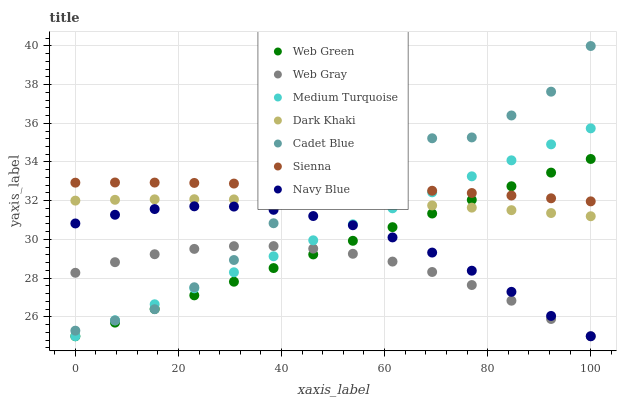Does Web Gray have the minimum area under the curve?
Answer yes or no. Yes. Does Sienna have the maximum area under the curve?
Answer yes or no. Yes. Does Navy Blue have the minimum area under the curve?
Answer yes or no. No. Does Navy Blue have the maximum area under the curve?
Answer yes or no. No. Is Medium Turquoise the smoothest?
Answer yes or no. Yes. Is Cadet Blue the roughest?
Answer yes or no. Yes. Is Web Gray the smoothest?
Answer yes or no. No. Is Web Gray the roughest?
Answer yes or no. No. Does Web Gray have the lowest value?
Answer yes or no. Yes. Does Dark Khaki have the lowest value?
Answer yes or no. No. Does Cadet Blue have the highest value?
Answer yes or no. Yes. Does Navy Blue have the highest value?
Answer yes or no. No. Is Dark Khaki less than Sienna?
Answer yes or no. Yes. Is Dark Khaki greater than Navy Blue?
Answer yes or no. Yes. Does Web Green intersect Dark Khaki?
Answer yes or no. Yes. Is Web Green less than Dark Khaki?
Answer yes or no. No. Is Web Green greater than Dark Khaki?
Answer yes or no. No. Does Dark Khaki intersect Sienna?
Answer yes or no. No. 